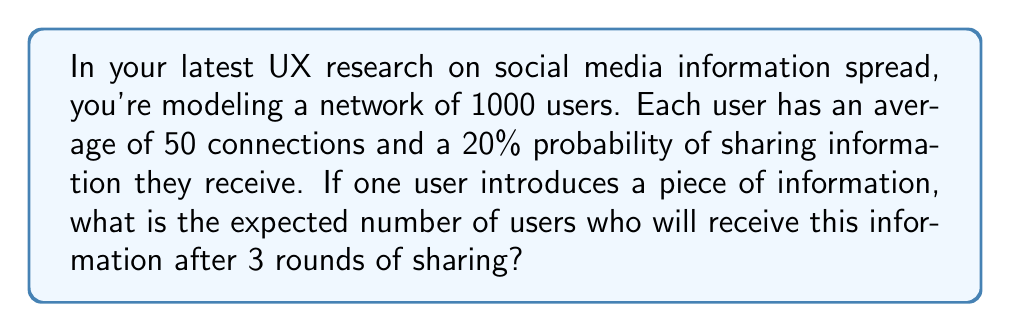Provide a solution to this math problem. Let's approach this step-by-step using an agent-based simulation model:

1) First, we need to calculate the number of users who receive the information in each round:

   Round 0: 1 user (the initial sharer)
   Round 1: $1 + (1 \times 50 \times 0.2) = 11$ users
   Round 2: $11 + (10 \times 50 \times 0.2) = 111$ users
   Round 3: $111 + (100 \times 50 \times 0.2) = 1111$ users

2) The formula for each round can be generalized as:

   $$U_n = U_{n-1} + (U_{n-1} - U_{n-2}) \times 50 \times 0.2$$

   Where $U_n$ is the number of users who have received the information after round n.

3) However, we need to cap this at the total number of users in the network (1000).

4) Therefore, the final calculation for round 3 is:

   $$\min(1111, 1000) = 1000$$

5) This means that after 3 rounds, we expect the information to reach all 1000 users in the network.

This model assumes a simplified network structure and doesn't account for factors like overlapping connections or diminishing returns, which a more complex UX research model might include.
Answer: 1000 users 